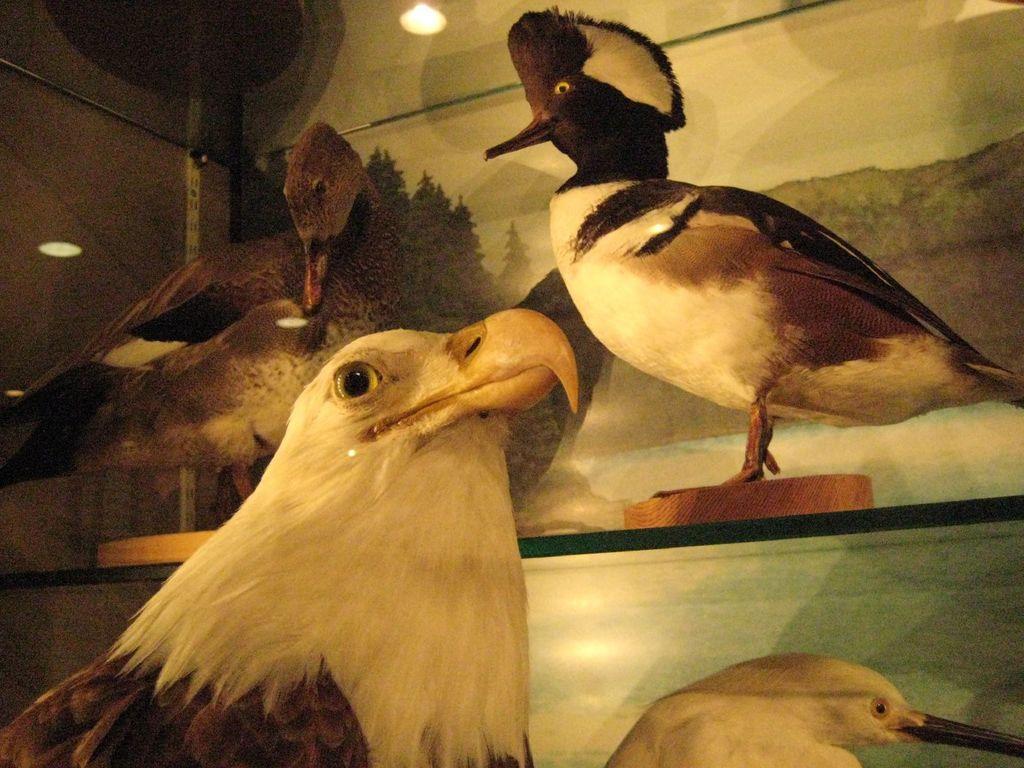Describe this image in one or two sentences. In this image we can see some birds in the shelves. On the backside we can see a wall and a light. 